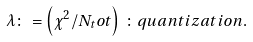<formula> <loc_0><loc_0><loc_500><loc_500>\lambda \colon = \left ( \chi ^ { 2 } / N _ { t } o t \right ) \, \colon q u a n t i z a t i o n .</formula> 